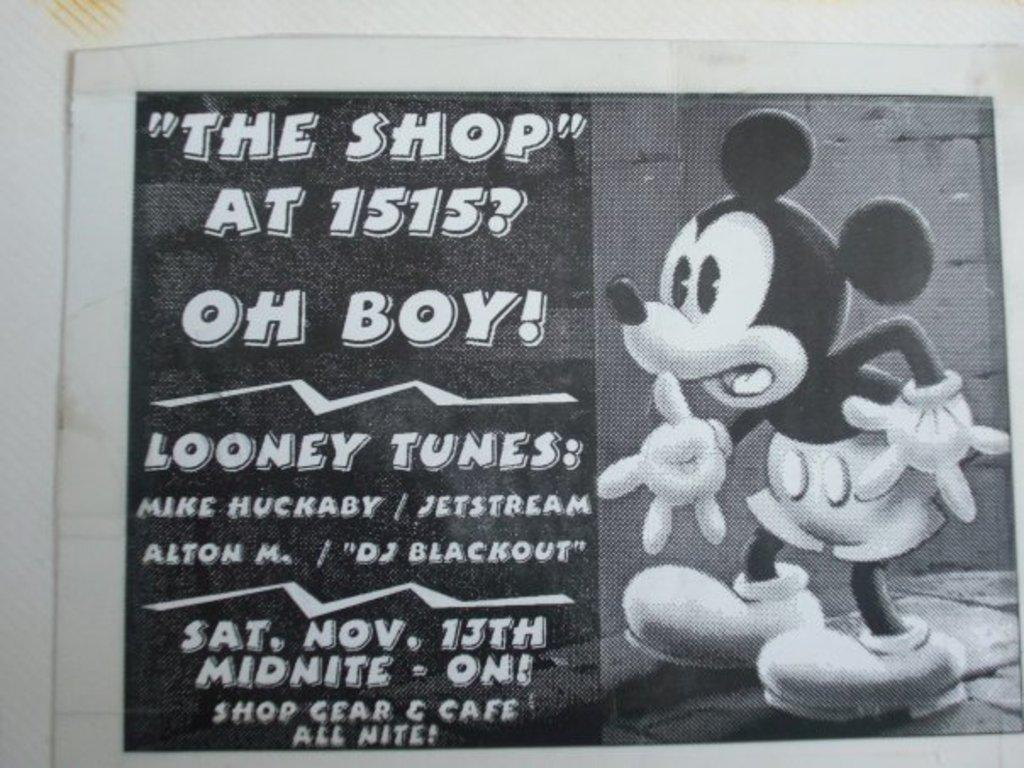What is featured on the poster in the image? The poster has an animated image of an animal. What color is the text on the poster? The poster has white text. What is the background of the poster? The poster is pasted on a white wall. What type of story is being told by the dust on the poster? There is no dust present on the poster, and therefore no story can be told by it. 